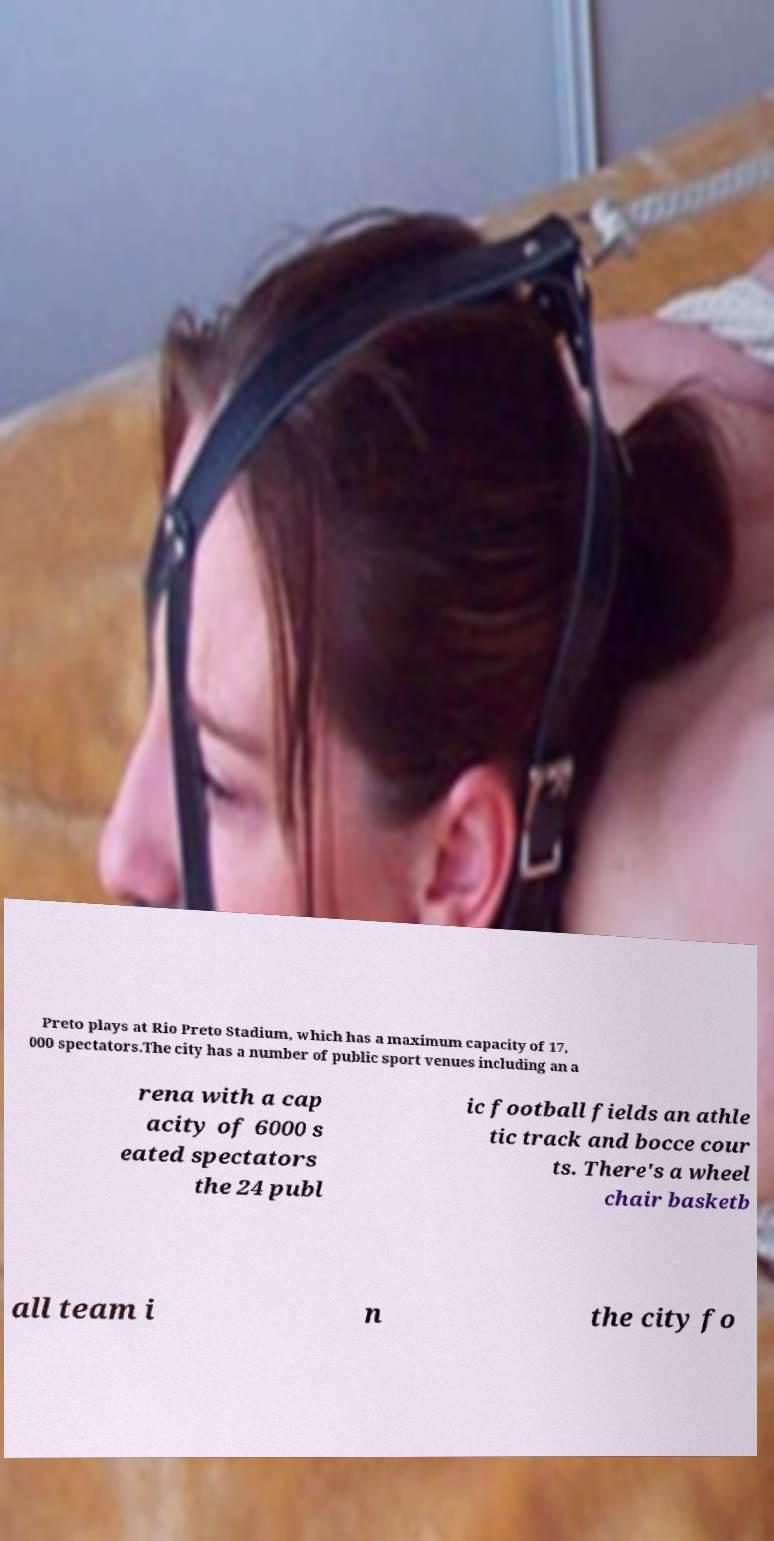Please read and relay the text visible in this image. What does it say? Preto plays at Rio Preto Stadium, which has a maximum capacity of 17, 000 spectators.The city has a number of public sport venues including an a rena with a cap acity of 6000 s eated spectators the 24 publ ic football fields an athle tic track and bocce cour ts. There's a wheel chair basketb all team i n the city fo 